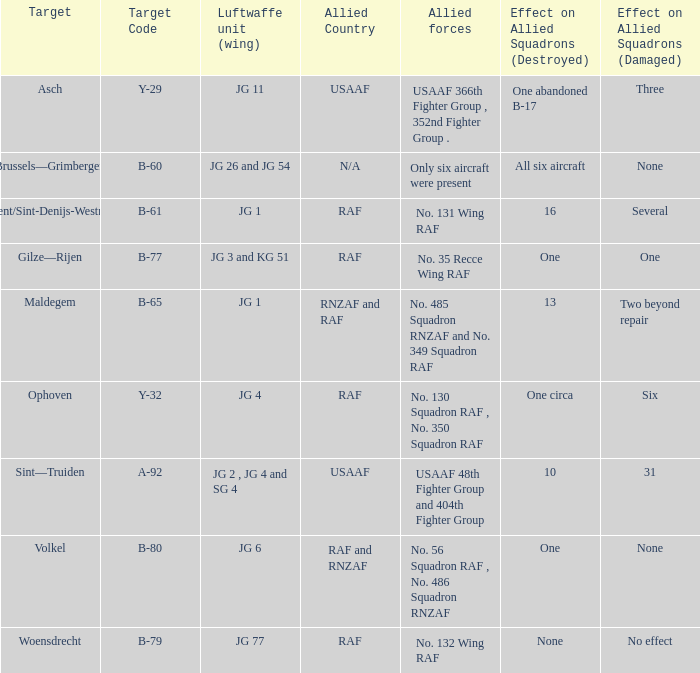What is the allied target code of the group that targetted ghent/sint-denijs-westrem? B-61. 